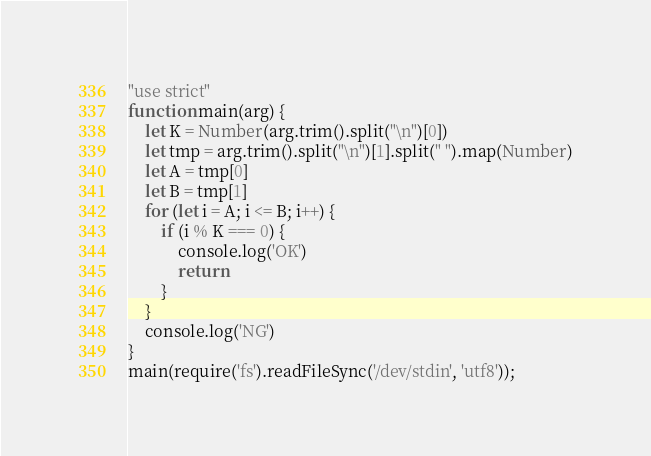<code> <loc_0><loc_0><loc_500><loc_500><_JavaScript_>"use strict"
function main(arg) {
    let K = Number(arg.trim().split("\n")[0])
    let tmp = arg.trim().split("\n")[1].split(" ").map(Number)
    let A = tmp[0]
    let B = tmp[1]
    for (let i = A; i <= B; i++) {
        if (i % K === 0) {
            console.log('OK')
            return
        }
    }
    console.log('NG')
}
main(require('fs').readFileSync('/dev/stdin', 'utf8'));</code> 